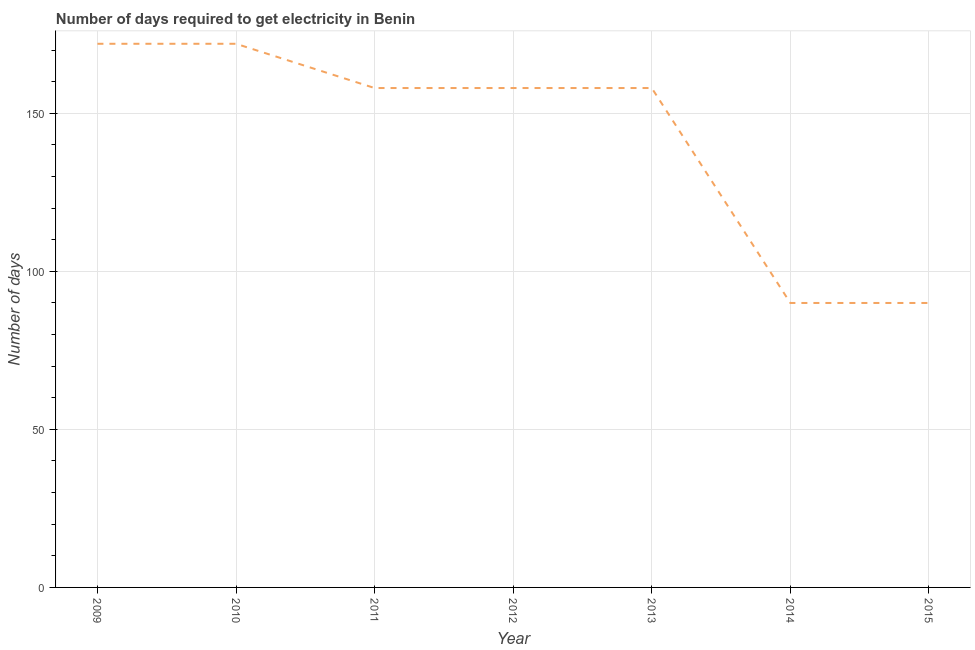What is the time to get electricity in 2012?
Provide a short and direct response. 158. Across all years, what is the maximum time to get electricity?
Ensure brevity in your answer.  172. Across all years, what is the minimum time to get electricity?
Offer a terse response. 90. In which year was the time to get electricity minimum?
Offer a terse response. 2014. What is the sum of the time to get electricity?
Your response must be concise. 998. What is the difference between the time to get electricity in 2013 and 2014?
Keep it short and to the point. 68. What is the average time to get electricity per year?
Your response must be concise. 142.57. What is the median time to get electricity?
Give a very brief answer. 158. In how many years, is the time to get electricity greater than 30 ?
Ensure brevity in your answer.  7. Do a majority of the years between 2009 and 2012 (inclusive) have time to get electricity greater than 10 ?
Make the answer very short. Yes. Is the time to get electricity in 2011 less than that in 2015?
Ensure brevity in your answer.  No. Is the difference between the time to get electricity in 2011 and 2012 greater than the difference between any two years?
Your answer should be compact. No. What is the difference between the highest and the second highest time to get electricity?
Provide a short and direct response. 0. Is the sum of the time to get electricity in 2010 and 2015 greater than the maximum time to get electricity across all years?
Keep it short and to the point. Yes. What is the difference between the highest and the lowest time to get electricity?
Offer a very short reply. 82. In how many years, is the time to get electricity greater than the average time to get electricity taken over all years?
Your answer should be very brief. 5. Does the time to get electricity monotonically increase over the years?
Ensure brevity in your answer.  No. How many lines are there?
Your response must be concise. 1. How many years are there in the graph?
Make the answer very short. 7. Are the values on the major ticks of Y-axis written in scientific E-notation?
Give a very brief answer. No. Does the graph contain grids?
Offer a terse response. Yes. What is the title of the graph?
Ensure brevity in your answer.  Number of days required to get electricity in Benin. What is the label or title of the X-axis?
Keep it short and to the point. Year. What is the label or title of the Y-axis?
Your answer should be very brief. Number of days. What is the Number of days in 2009?
Offer a very short reply. 172. What is the Number of days of 2010?
Offer a very short reply. 172. What is the Number of days in 2011?
Your response must be concise. 158. What is the Number of days of 2012?
Provide a succinct answer. 158. What is the Number of days in 2013?
Your answer should be compact. 158. What is the Number of days in 2015?
Make the answer very short. 90. What is the difference between the Number of days in 2009 and 2010?
Offer a very short reply. 0. What is the difference between the Number of days in 2009 and 2011?
Make the answer very short. 14. What is the difference between the Number of days in 2009 and 2012?
Provide a succinct answer. 14. What is the difference between the Number of days in 2009 and 2013?
Offer a terse response. 14. What is the difference between the Number of days in 2009 and 2014?
Ensure brevity in your answer.  82. What is the difference between the Number of days in 2009 and 2015?
Your answer should be very brief. 82. What is the difference between the Number of days in 2010 and 2012?
Keep it short and to the point. 14. What is the difference between the Number of days in 2010 and 2014?
Give a very brief answer. 82. What is the difference between the Number of days in 2011 and 2013?
Make the answer very short. 0. What is the difference between the Number of days in 2011 and 2015?
Ensure brevity in your answer.  68. What is the difference between the Number of days in 2013 and 2014?
Give a very brief answer. 68. What is the difference between the Number of days in 2013 and 2015?
Your answer should be very brief. 68. What is the ratio of the Number of days in 2009 to that in 2010?
Offer a terse response. 1. What is the ratio of the Number of days in 2009 to that in 2011?
Make the answer very short. 1.09. What is the ratio of the Number of days in 2009 to that in 2012?
Give a very brief answer. 1.09. What is the ratio of the Number of days in 2009 to that in 2013?
Your response must be concise. 1.09. What is the ratio of the Number of days in 2009 to that in 2014?
Provide a short and direct response. 1.91. What is the ratio of the Number of days in 2009 to that in 2015?
Offer a terse response. 1.91. What is the ratio of the Number of days in 2010 to that in 2011?
Keep it short and to the point. 1.09. What is the ratio of the Number of days in 2010 to that in 2012?
Provide a succinct answer. 1.09. What is the ratio of the Number of days in 2010 to that in 2013?
Provide a succinct answer. 1.09. What is the ratio of the Number of days in 2010 to that in 2014?
Offer a very short reply. 1.91. What is the ratio of the Number of days in 2010 to that in 2015?
Keep it short and to the point. 1.91. What is the ratio of the Number of days in 2011 to that in 2014?
Provide a succinct answer. 1.76. What is the ratio of the Number of days in 2011 to that in 2015?
Your answer should be compact. 1.76. What is the ratio of the Number of days in 2012 to that in 2013?
Your answer should be compact. 1. What is the ratio of the Number of days in 2012 to that in 2014?
Your answer should be very brief. 1.76. What is the ratio of the Number of days in 2012 to that in 2015?
Offer a terse response. 1.76. What is the ratio of the Number of days in 2013 to that in 2014?
Ensure brevity in your answer.  1.76. What is the ratio of the Number of days in 2013 to that in 2015?
Provide a succinct answer. 1.76. 